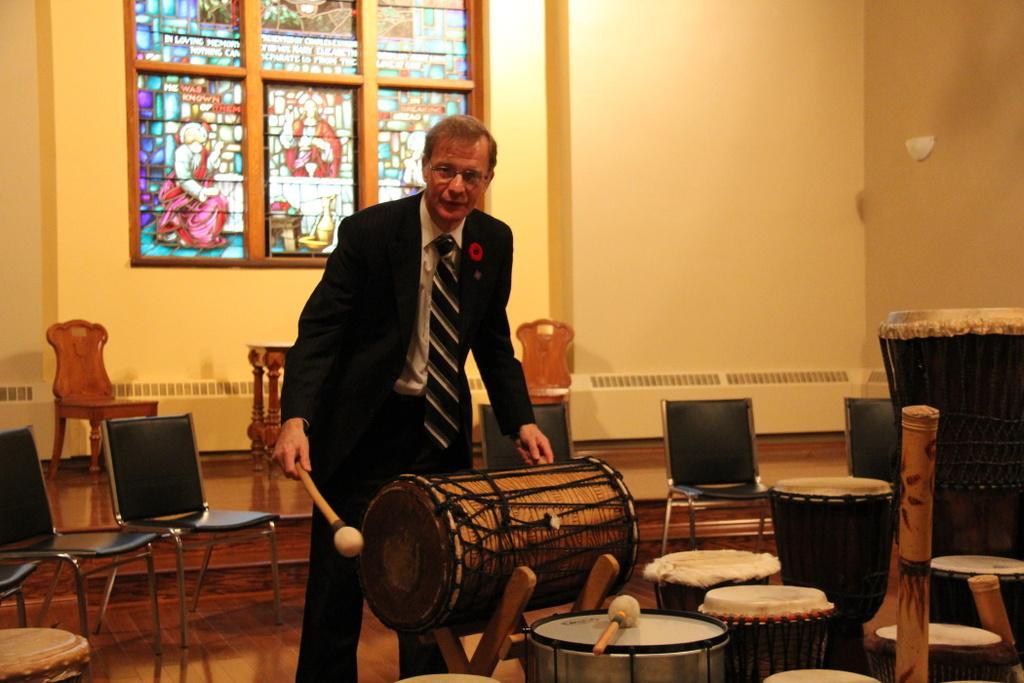Could you give a brief overview of what you see in this image? In this image I see a man who is standing and I see that he is wearing suit which is of black in color and I see that he is holding a stick in one hand and a musical instrument in other hand and I see few more musical instruments over here and in the background I see the chairs and I see the floor and I see the wall and I see an art over here. 